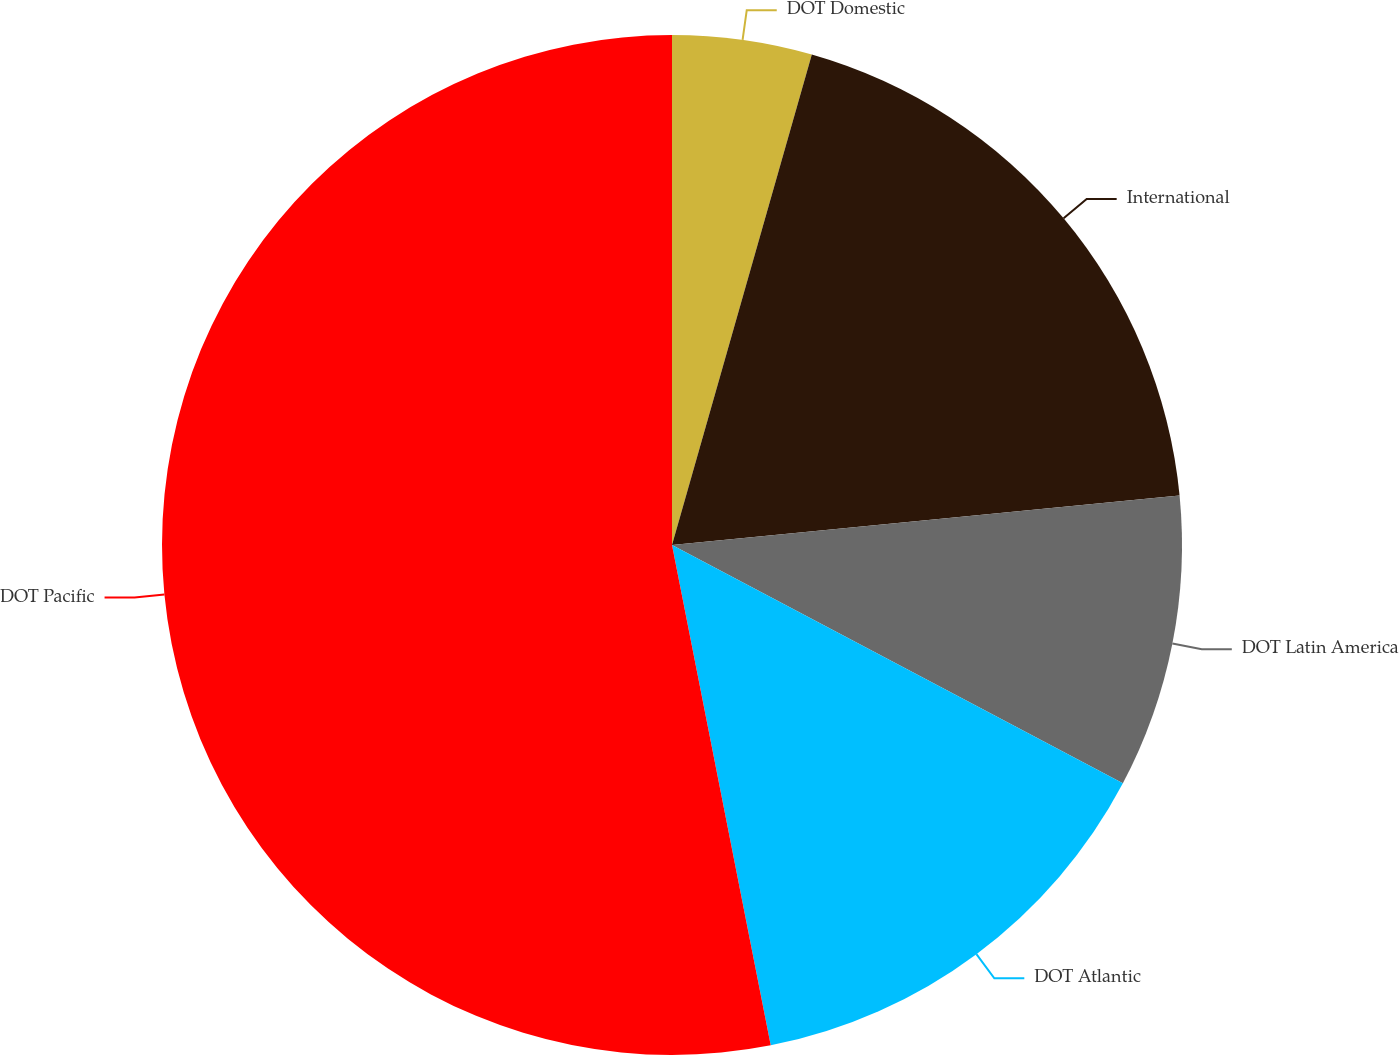Convert chart. <chart><loc_0><loc_0><loc_500><loc_500><pie_chart><fcel>DOT Domestic<fcel>International<fcel>DOT Latin America<fcel>DOT Atlantic<fcel>DOT Pacific<nl><fcel>4.42%<fcel>19.03%<fcel>9.29%<fcel>14.16%<fcel>53.1%<nl></chart> 